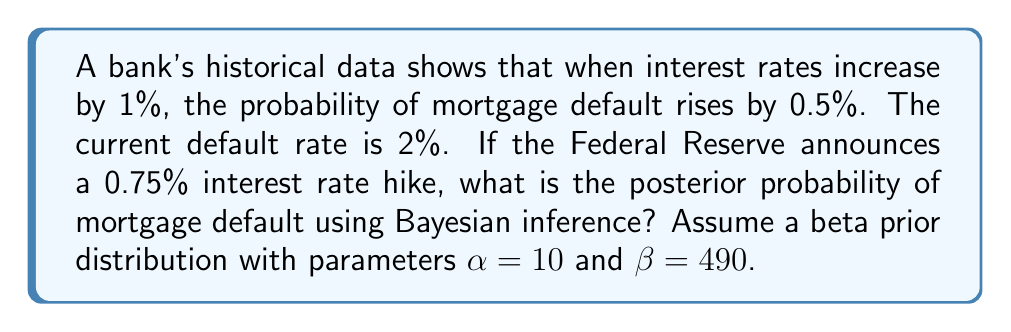Provide a solution to this math problem. To solve this problem using Bayesian inference, we'll follow these steps:

1) First, let's define our prior distribution. We're given a beta distribution with $\alpha=10$ and $\beta=490$. The mean of this distribution is:

   $$\mu_{prior} = \frac{\alpha}{\alpha + \beta} = \frac{10}{10 + 490} = 0.02 = 2\%$$

   This aligns with the current default rate.

2) Now, we need to update our belief based on the new information. The interest rate is increasing by 0.75%, and we're told that for every 1% increase, the default probability increases by 0.5%. So, we expect the default rate to increase by:

   $$0.75 * 0.5\% = 0.375\%$$

3) This gives us a new expected default rate of:

   $$2\% + 0.375\% = 2.375\%$$

4) In Bayesian terms, this new information serves as our likelihood. To update our prior, we need to determine how many "virtual" observations this new information represents. Let's assume it's equivalent to 100 new observations.

5) Out of these 100 new observations, we expect 2.375 defaults (2.375% of 100). Let's call this $y$.

6) Now we can update our beta distribution. The posterior distribution will also be a beta distribution with parameters:

   $$\alpha_{posterior} = \alpha_{prior} + y = 10 + 2.375 = 12.375$$
   $$\beta_{posterior} = \beta_{prior} + (n - y) = 490 + (100 - 2.375) = 587.625$$

7) The posterior mean (our new estimate of the default probability) is:

   $$\mu_{posterior} = \frac{\alpha_{posterior}}{\alpha_{posterior} + \beta_{posterior}} = \frac{12.375}{12.375 + 587.625} = 0.02062 = 2.062\%$$

This is our Bayesian estimate of the new default probability after the interest rate hike.
Answer: The posterior probability of mortgage default is approximately 2.062%. 